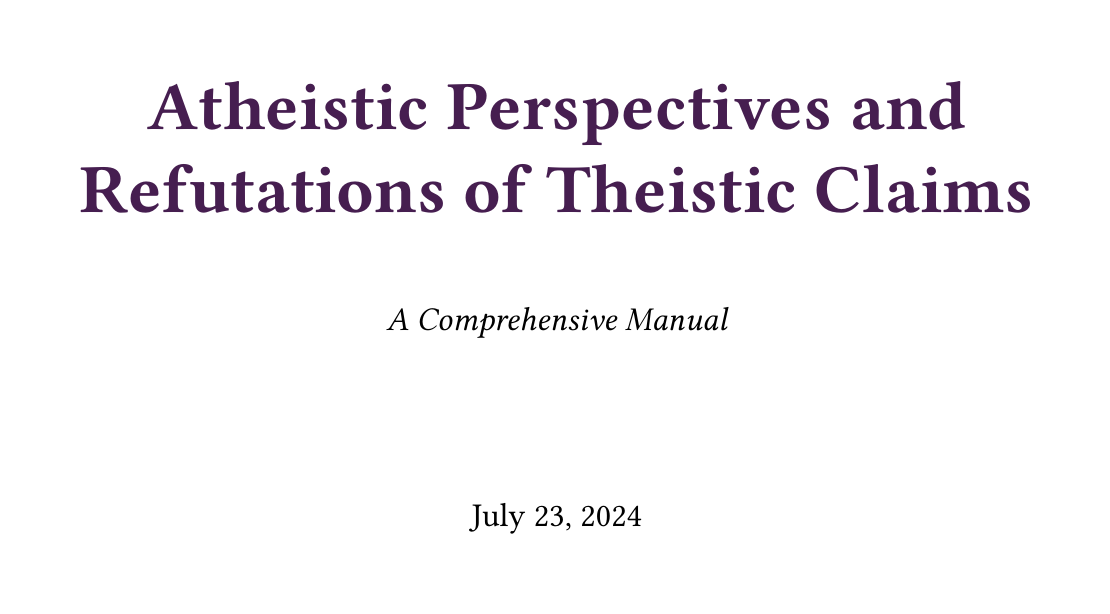What is the title of the document? The title is prominently displayed on the first page of the document.
Answer: Atheistic Perspectives and Refutations of Theistic Claims: A Comprehensive Manual Who is one of the notable atheist philosophers mentioned? The document lists several notable atheist philosophers in a dedicated section.
Answer: Friedrich Nietzsche What approach is explained in the second section? The document categorizes its content into several approaches, with the second section focusing on a specific perspective.
Answer: Logical Approaches to Atheism How many subsections are there in the section on Evidential Arguments Against Theism? The number of subsections is provided in the outline of the document's table of contents.
Answer: Four What argument is associated with Bertrand Russell in the logical approaches? The document includes a specific analogy linked to Bertrand Russell in its discussions about logical approaches to atheism.
Answer: Teapot analogy What philosophical concept is mentioned in the Key Concepts section? The document provides a list of key concepts relevant to the discussions within it.
Answer: Falsifiability Which contemporary atheist thought is discussed in the document? There is a section dedicated to contemporary atheist movements and key figures.
Answer: New Atheism What is one of the critiques addressed in the Refutations section? The document addresses various common theistic arguments within its refutations.
Answer: Cosmological argument What is the role of philosophy in the context of the future of atheism according to the conclusion? The document outlines key themes within its conclusion, addressing the philosophical implications of atheism.
Answer: Shaping atheist discourse 